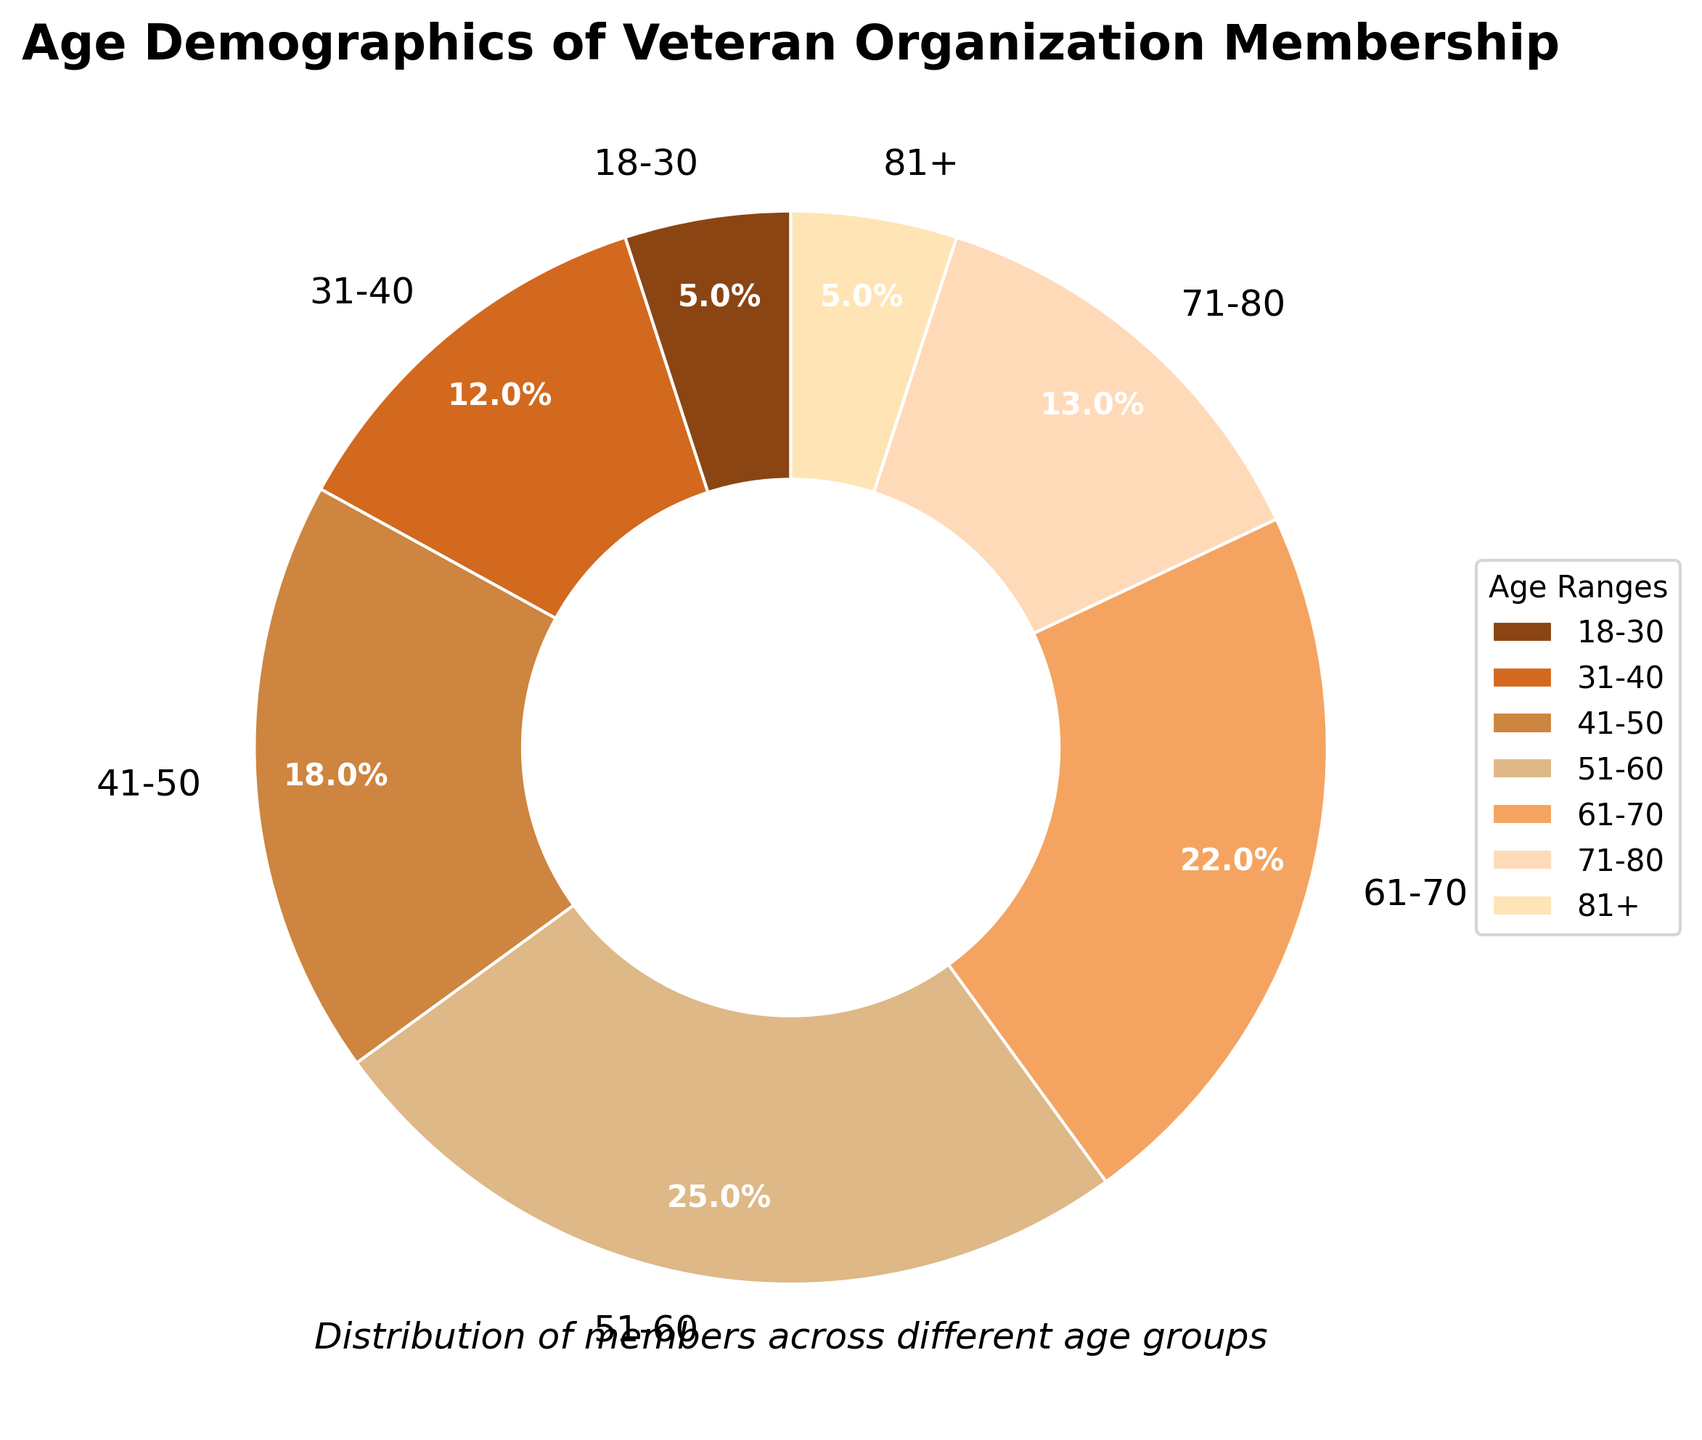What age range has the largest percentage of membership? By looking at the pie chart, we see that the segment labeled "51-60" occupies the largest portion of the chart. This visual indication shows the highest percentage of membership.
Answer: 51-60 What is the combined percentage of members aged 71 and older? To find the combined percentage of the "71-80" and "81+" age ranges, we add their respective percentages: 13% + 5% = 18%.
Answer: 18% Which age range has a higher membership percentage: 31-40 or 61-70? By comparing the two segments on the pie chart, the "61-70" age range (22%) is visually larger than the "31-40" age range (12%). Therefore, 61-70 has a higher percentage.
Answer: 61-70 What is the difference in percentage between the youngest (18-30) and the oldest (81+) age groups? We find the difference by subtracting the percentage of the oldest age group (81+) from the youngest age group (18-30): 5% - 5% = 0%.
Answer: 0% What age groups combined make up more than half (over 50%) of the membership? By examining and summing the larger segments: 51-60 (25%) + 61-70 (22%) = 47%, then adding the next largest, 41-50 (18%) + 47% = 65%. Therefore, 41-50, 51-60, and 61-70 combined make up more than half.
Answer: 41-50, 51-60, 61-70 How much greater is the percentage of members aged 51-60 compared to those aged 18-30? The difference can be calculated by subtracting the percentage of the 18-30 age group (5%) from the 51-60 age group (25%): 25% - 5% = 20%.
Answer: 20% What is the total percentage of members aged between 31 and 50? Adding the percentages for the age groups 31-40 and 41-50 gives us: 12% + 18% = 30%.
Answer: 30% Which color represents the age group 51-60 in the pie chart? The color associated with the 51-60 age group can be identified visually from the legend provided next to the pie chart.
Answer: Brown (or equivalent color descriptor) What portion of the pie chart represents members older than 50? Summing the percentages of members aged 51-60, 61-70, 71-80, and 81+ gives: 25% + 22% + 13% + 5% = 65%.
Answer: 65% Which age group has a similar membership percentage as the 18-30 age group? Both the 18-30 and 81+ age groups show 5% membership, indicating similar proportions represented on the pie chart.
Answer: 81+ 